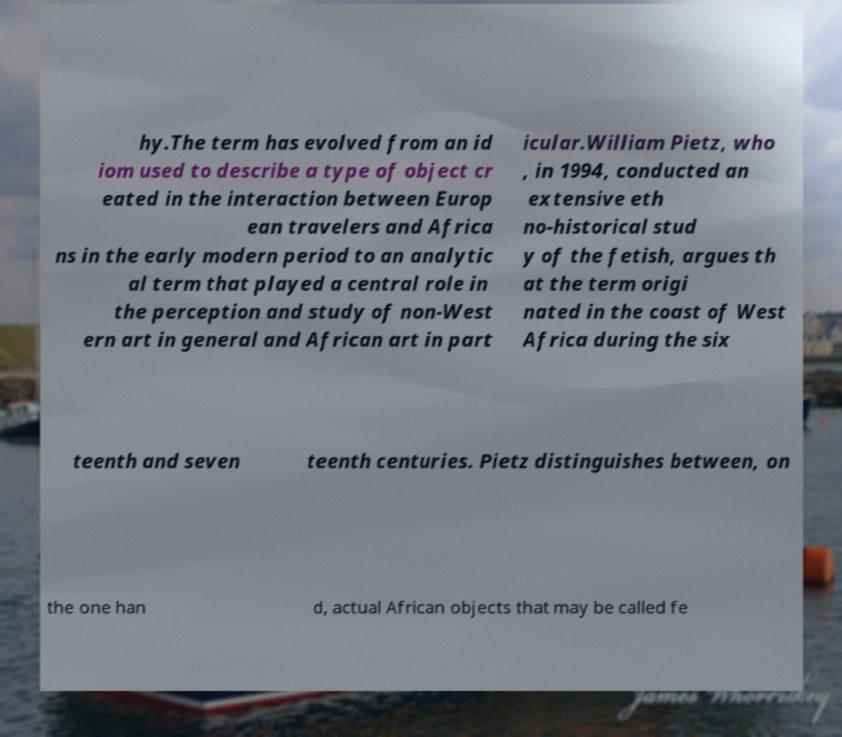For documentation purposes, I need the text within this image transcribed. Could you provide that? hy.The term has evolved from an id iom used to describe a type of object cr eated in the interaction between Europ ean travelers and Africa ns in the early modern period to an analytic al term that played a central role in the perception and study of non-West ern art in general and African art in part icular.William Pietz, who , in 1994, conducted an extensive eth no-historical stud y of the fetish, argues th at the term origi nated in the coast of West Africa during the six teenth and seven teenth centuries. Pietz distinguishes between, on the one han d, actual African objects that may be called fe 